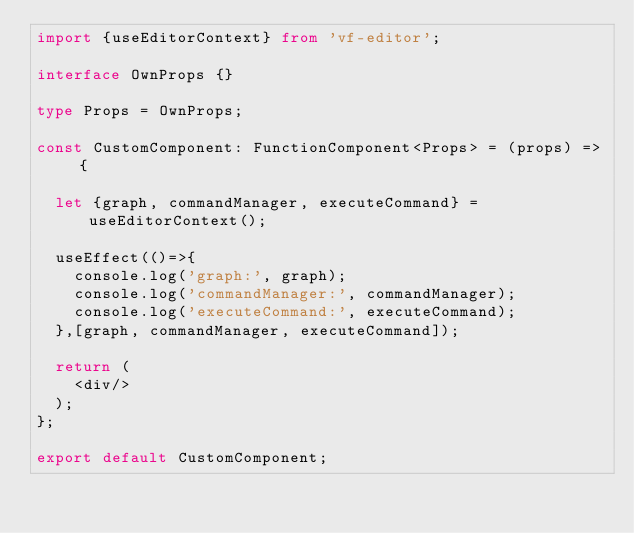Convert code to text. <code><loc_0><loc_0><loc_500><loc_500><_TypeScript_>import {useEditorContext} from 'vf-editor';

interface OwnProps {}

type Props = OwnProps;

const CustomComponent: FunctionComponent<Props> = (props) => {

  let {graph, commandManager, executeCommand} = useEditorContext();

  useEffect(()=>{
    console.log('graph:', graph);
    console.log('commandManager:', commandManager);
    console.log('executeCommand:', executeCommand);
  },[graph, commandManager, executeCommand]);

  return (
    <div/>
  );
};

export default CustomComponent;
</code> 